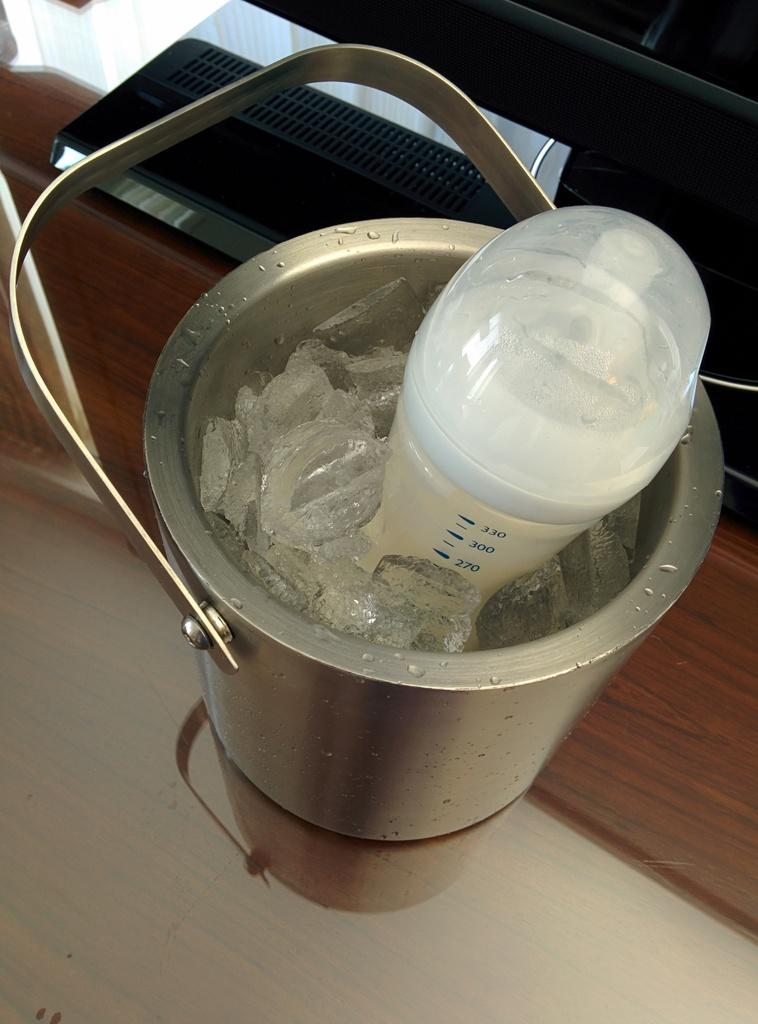What is inside the container that is visible in the image? There is a container with ice in the image. What device is used to measure temperature in the image? There is a temperature instrument in the image. What is the object on the platform in the image? The facts do not specify the object on the platform, so we cannot answer this question definitively. How does the stomach feel in the image? There is no stomach present in the image, so we cannot answer this question. What type of needle is used in the image? There is no needle present in the image, so we cannot answer this question. 